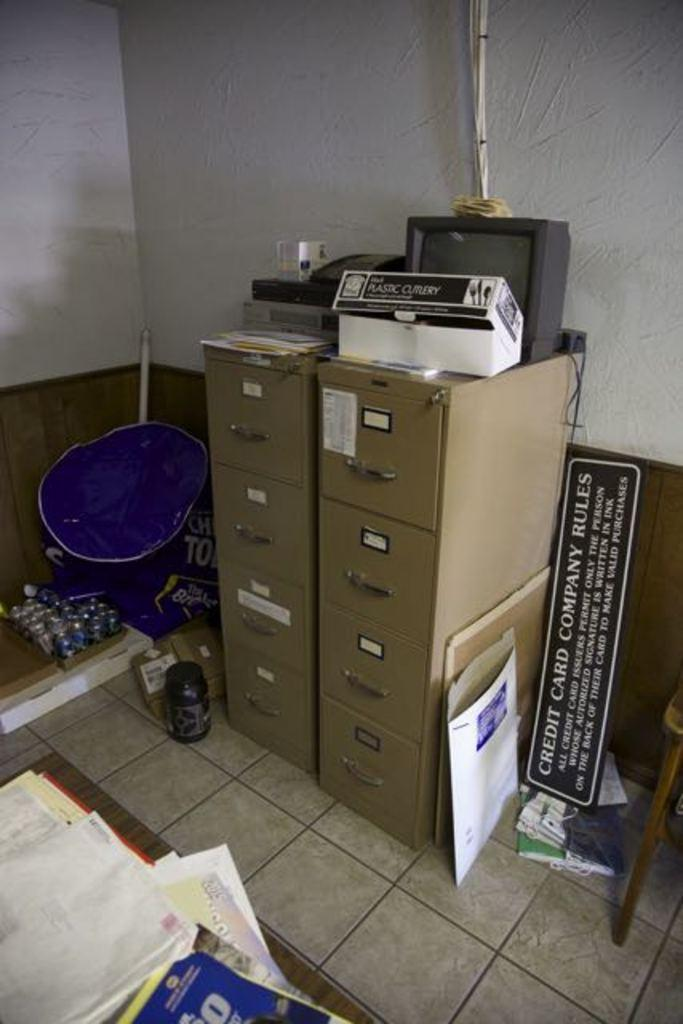What electronic device is present in the image? There is a television in the image. What is connected to the television in the image? Cable wires are visible in the image. What type of furniture is present in the image? There are cupboards in the image. What surface is the board placed on in the image? The board is placed on a wall in the image. What type of material is present in the image? Papers are present in the image. What part of the room is visible in the image? The floor is visible in the image. What type of structure is present in the image? There are walls in the image. What type of guitar is being played by the sun in the image? There is no guitar or sun present in the image. 